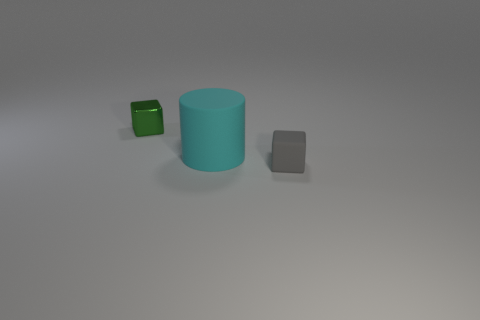Is there any other thing that is the same shape as the large object?
Your answer should be very brief. No. Are there any other things that are the same size as the cyan thing?
Your response must be concise. No. There is a block that is behind the small gray thing; is its size the same as the matte object on the left side of the tiny matte object?
Your response must be concise. No. Is the number of green shiny blocks less than the number of blue rubber balls?
Provide a succinct answer. No. What number of rubber objects are either small green cubes or big spheres?
Provide a short and direct response. 0. Are there any gray objects that are behind the tiny cube that is on the right side of the green object?
Make the answer very short. No. Does the thing that is behind the matte cylinder have the same material as the cyan object?
Your response must be concise. No. What is the size of the matte object that is on the left side of the small block in front of the large cylinder?
Your response must be concise. Large. Do the block to the right of the tiny green metallic block and the thing that is behind the large cyan rubber cylinder have the same material?
Make the answer very short. No. There is a tiny green thing; how many big cylinders are in front of it?
Provide a succinct answer. 1. 